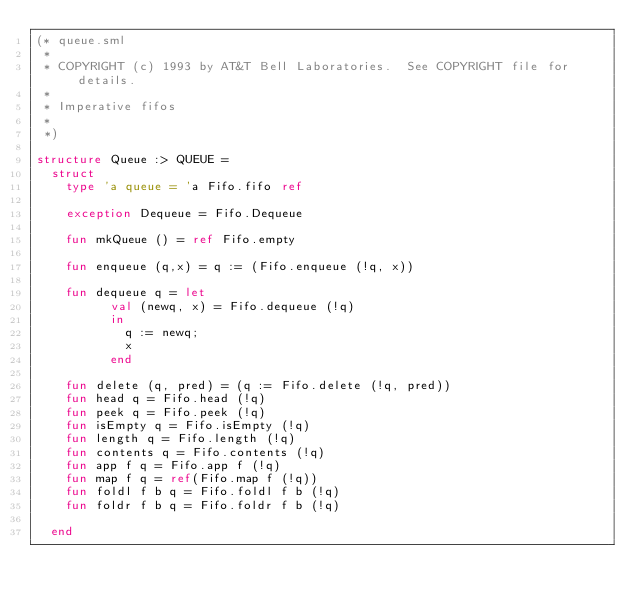Convert code to text. <code><loc_0><loc_0><loc_500><loc_500><_SML_>(* queue.sml
 *
 * COPYRIGHT (c) 1993 by AT&T Bell Laboratories.  See COPYRIGHT file for details.
 *
 * Imperative fifos
 *
 *)

structure Queue :> QUEUE =
  struct
    type 'a queue = 'a Fifo.fifo ref

    exception Dequeue = Fifo.Dequeue

    fun mkQueue () = ref Fifo.empty

    fun enqueue (q,x) = q := (Fifo.enqueue (!q, x))

    fun dequeue q = let
          val (newq, x) = Fifo.dequeue (!q)
          in
            q := newq;
            x
          end

    fun delete (q, pred) = (q := Fifo.delete (!q, pred))
    fun head q = Fifo.head (!q)
    fun peek q = Fifo.peek (!q)
    fun isEmpty q = Fifo.isEmpty (!q)
    fun length q = Fifo.length (!q)
    fun contents q = Fifo.contents (!q)
    fun app f q = Fifo.app f (!q)
    fun map f q = ref(Fifo.map f (!q))
    fun foldl f b q = Fifo.foldl f b (!q)
    fun foldr f b q = Fifo.foldr f b (!q)

  end
</code> 